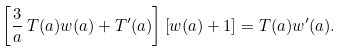<formula> <loc_0><loc_0><loc_500><loc_500>\left [ \frac { 3 } { a } \, T ( a ) w ( a ) + T ^ { \prime } ( a ) \right ] \left [ w ( a ) + 1 \right ] = T ( a ) w ^ { \prime } ( a ) .</formula> 